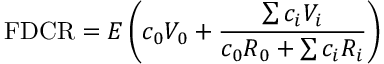<formula> <loc_0><loc_0><loc_500><loc_500>F D C R = E \left ( c _ { 0 } V _ { 0 } + { \frac { \sum c _ { i } V _ { i } } { c _ { 0 } R _ { 0 } + \sum c _ { i } R _ { i } } } \right )</formula> 